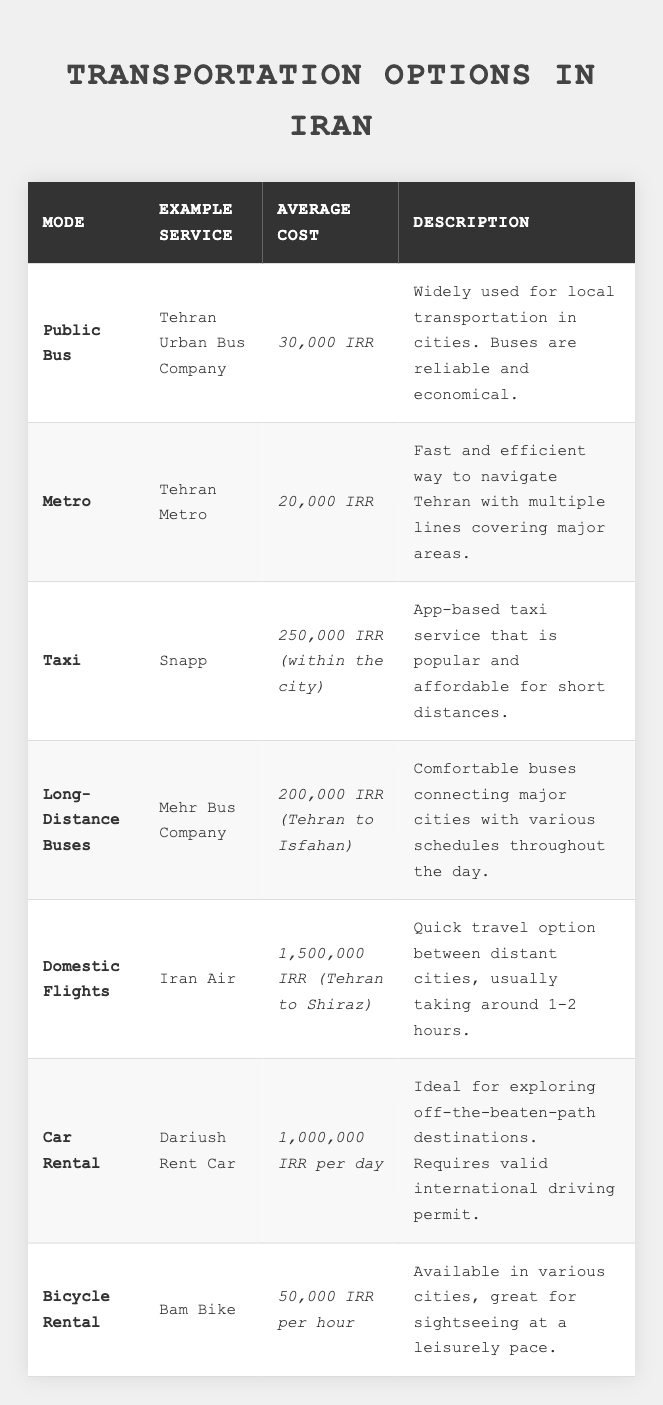What is the average cost of using the Metro in Iran? The table indicates that the average cost for using the Metro service is 20,000 IRR.
Answer: 20,000 IRR Which transportation mode is the cheapest for local travel? According to the table, the cheapest option for local travel is the Metro at an average cost of 20,000 IRR.
Answer: Metro What is the average cost of renting a bicycle for three hours? The rental cost for a bicycle is 50,000 IRR per hour, so for three hours, the cost would be 50,000 IRR * 3 = 150,000 IRR.
Answer: 150,000 IRR Are domestic flights the most expensive transportation option listed? The average cost of domestic flights is 1,500,000 IRR, which is higher than all other transportation options listed in the table, making it the most expensive.
Answer: Yes How much more expensive is a taxi ride compared to using the Metro for a local trip? The taxi ride costs 250,000 IRR while the Metro costs 20,000 IRR. The difference is 250,000 IRR - 20,000 IRR = 230,000 IRR.
Answer: 230,000 IRR What is the total cost if a tourist chooses to travel from Tehran to Isfahan by long-distance bus and then rents a car for a day? The cost of the long-distance bus from Tehran to Isfahan is 200,000 IRR, and renting a car for a day costs 1,000,000 IRR. Therefore, the total cost would be 200,000 IRR + 1,000,000 IRR = 1,200,000 IRR.
Answer: 1,200,000 IRR If a tourist takes both the Metro and the public bus on the same day, how much will they spend in total? The Metro costs 20,000 IRR and the public bus costs 30,000 IRR. The total cost would be 20,000 IRR + 30,000 IRR = 50,000 IRR.
Answer: 50,000 IRR What is the cost of traveling from Tehran to Shiraz by domestic flight compared to long-distance bus? The domestic flight costs 1,500,000 IRR, while the long-distance bus from Tehran to Isfahan is 200,000 IRR. The flight is significantly more expensive.
Answer: Yes If a tourist wants to visit four different cities, which option would be the most convenient based on the table? Renting a car at 1,000,000 IRR per day could be the most convenient option for visiting multiple cities, as it provides flexibility compared to fixed bus or flight schedules.
Answer: Car Rental How long does a domestic flight take from Tehran to Shiraz? The table states that the flight usually takes around 1-2 hours, which provides a quick travel option between the two cities.
Answer: 1-2 hours 